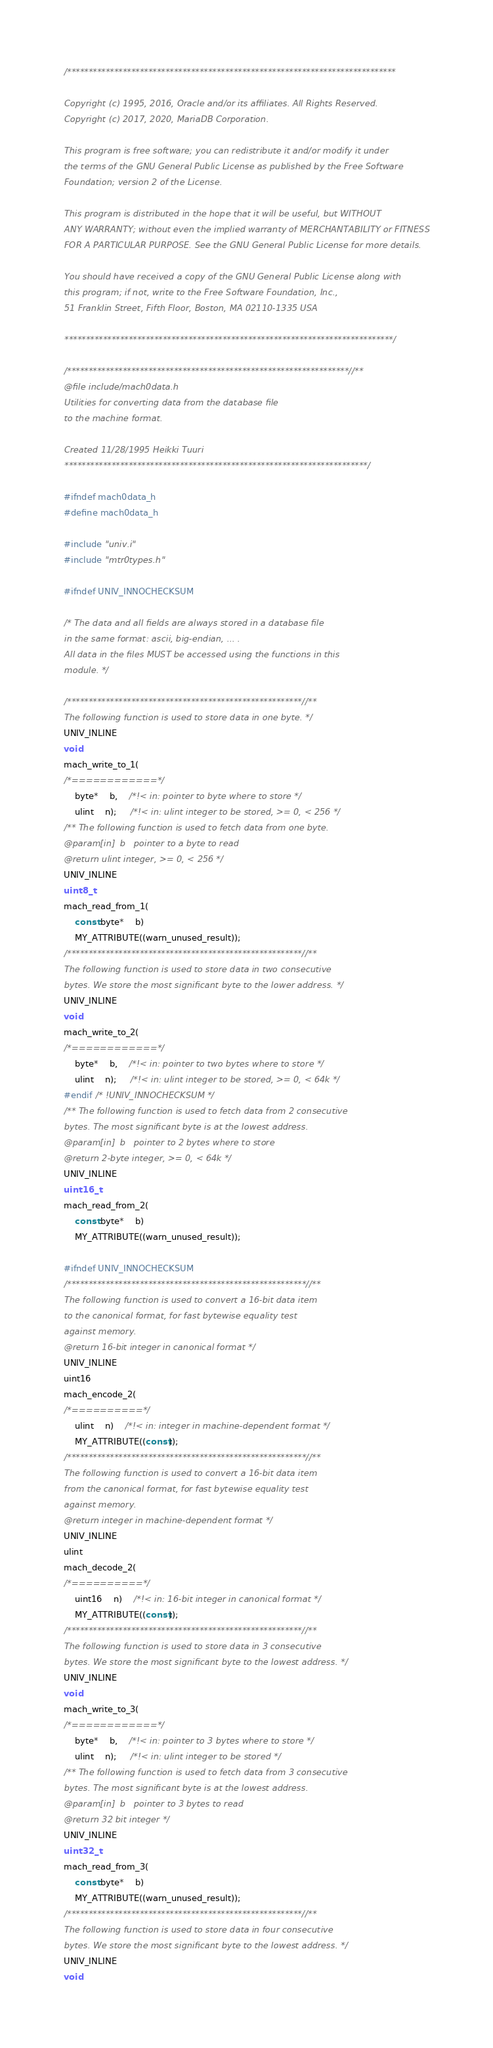<code> <loc_0><loc_0><loc_500><loc_500><_C_>/*****************************************************************************

Copyright (c) 1995, 2016, Oracle and/or its affiliates. All Rights Reserved.
Copyright (c) 2017, 2020, MariaDB Corporation.

This program is free software; you can redistribute it and/or modify it under
the terms of the GNU General Public License as published by the Free Software
Foundation; version 2 of the License.

This program is distributed in the hope that it will be useful, but WITHOUT
ANY WARRANTY; without even the implied warranty of MERCHANTABILITY or FITNESS
FOR A PARTICULAR PURPOSE. See the GNU General Public License for more details.

You should have received a copy of the GNU General Public License along with
this program; if not, write to the Free Software Foundation, Inc.,
51 Franklin Street, Fifth Floor, Boston, MA 02110-1335 USA

*****************************************************************************/

/******************************************************************//**
@file include/mach0data.h
Utilities for converting data from the database file
to the machine format.

Created 11/28/1995 Heikki Tuuri
***********************************************************************/

#ifndef mach0data_h
#define mach0data_h

#include "univ.i"
#include "mtr0types.h"

#ifndef UNIV_INNOCHECKSUM

/* The data and all fields are always stored in a database file
in the same format: ascii, big-endian, ... .
All data in the files MUST be accessed using the functions in this
module. */

/*******************************************************//**
The following function is used to store data in one byte. */
UNIV_INLINE
void
mach_write_to_1(
/*============*/
	byte*	b,	/*!< in: pointer to byte where to store */
	ulint	n);	 /*!< in: ulint integer to be stored, >= 0, < 256 */
/** The following function is used to fetch data from one byte.
@param[in]	b	pointer to a byte to read
@return ulint integer, >= 0, < 256 */
UNIV_INLINE
uint8_t
mach_read_from_1(
	const byte*	b)
	MY_ATTRIBUTE((warn_unused_result));
/*******************************************************//**
The following function is used to store data in two consecutive
bytes. We store the most significant byte to the lower address. */
UNIV_INLINE
void
mach_write_to_2(
/*============*/
	byte*	b,	/*!< in: pointer to two bytes where to store */
	ulint	n);	 /*!< in: ulint integer to be stored, >= 0, < 64k */
#endif /* !UNIV_INNOCHECKSUM */
/** The following function is used to fetch data from 2 consecutive
bytes. The most significant byte is at the lowest address.
@param[in]	b	pointer to 2 bytes where to store
@return 2-byte integer, >= 0, < 64k */
UNIV_INLINE
uint16_t
mach_read_from_2(
	const byte*	b)
	MY_ATTRIBUTE((warn_unused_result));

#ifndef UNIV_INNOCHECKSUM
/********************************************************//**
The following function is used to convert a 16-bit data item
to the canonical format, for fast bytewise equality test
against memory.
@return 16-bit integer in canonical format */
UNIV_INLINE
uint16
mach_encode_2(
/*==========*/
	ulint	n)	/*!< in: integer in machine-dependent format */
	MY_ATTRIBUTE((const));
/********************************************************//**
The following function is used to convert a 16-bit data item
from the canonical format, for fast bytewise equality test
against memory.
@return integer in machine-dependent format */
UNIV_INLINE
ulint
mach_decode_2(
/*==========*/
	uint16	n)	/*!< in: 16-bit integer in canonical format */
	MY_ATTRIBUTE((const));
/*******************************************************//**
The following function is used to store data in 3 consecutive
bytes. We store the most significant byte to the lowest address. */
UNIV_INLINE
void
mach_write_to_3(
/*============*/
	byte*	b,	/*!< in: pointer to 3 bytes where to store */
	ulint	n);	 /*!< in: ulint integer to be stored */
/** The following function is used to fetch data from 3 consecutive
bytes. The most significant byte is at the lowest address.
@param[in]	b	pointer to 3 bytes to read
@return 32 bit integer */
UNIV_INLINE
uint32_t
mach_read_from_3(
	const byte*	b)
	MY_ATTRIBUTE((warn_unused_result));
/*******************************************************//**
The following function is used to store data in four consecutive
bytes. We store the most significant byte to the lowest address. */
UNIV_INLINE
void</code> 